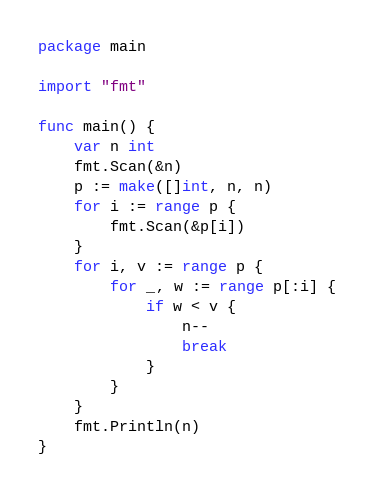Convert code to text. <code><loc_0><loc_0><loc_500><loc_500><_Go_>package main

import "fmt"

func main() {
	var n int
	fmt.Scan(&n)
	p := make([]int, n, n)
	for i := range p {
		fmt.Scan(&p[i])
	}
	for i, v := range p {
		for _, w := range p[:i] {
			if w < v {
				n--
				break
			}
		}
	}
	fmt.Println(n)
}
</code> 